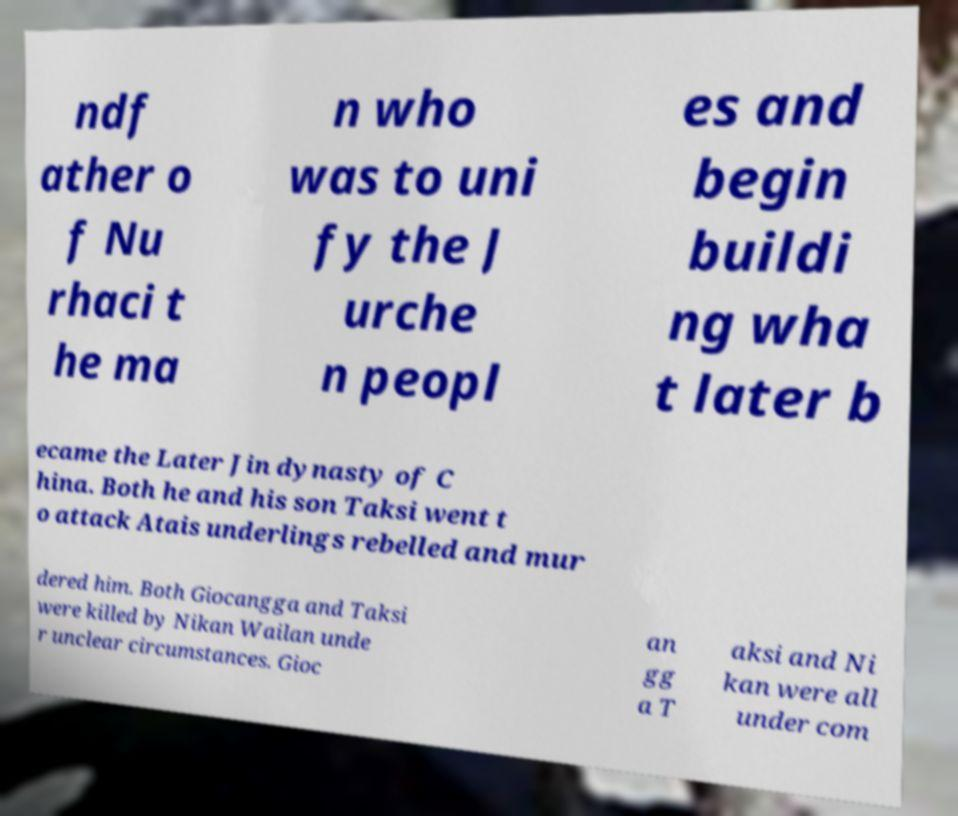Could you assist in decoding the text presented in this image and type it out clearly? ndf ather o f Nu rhaci t he ma n who was to uni fy the J urche n peopl es and begin buildi ng wha t later b ecame the Later Jin dynasty of C hina. Both he and his son Taksi went t o attack Atais underlings rebelled and mur dered him. Both Giocangga and Taksi were killed by Nikan Wailan unde r unclear circumstances. Gioc an gg a T aksi and Ni kan were all under com 